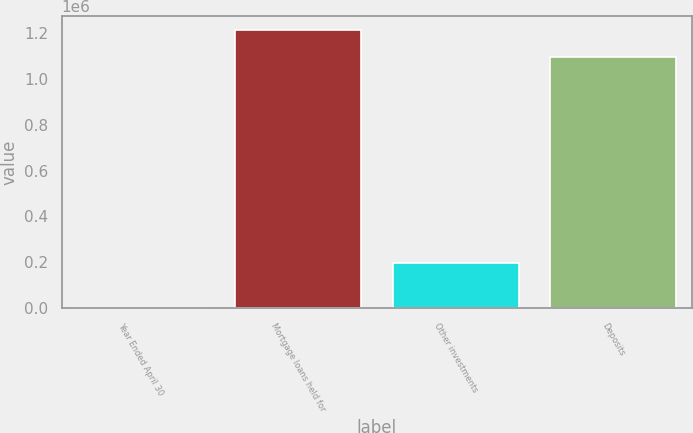Convert chart. <chart><loc_0><loc_0><loc_500><loc_500><bar_chart><fcel>Year Ended April 30<fcel>Mortgage loans held for<fcel>Other investments<fcel>Deposits<nl><fcel>2008<fcel>1.21092e+06<fcel>196262<fcel>1.09416e+06<nl></chart> 